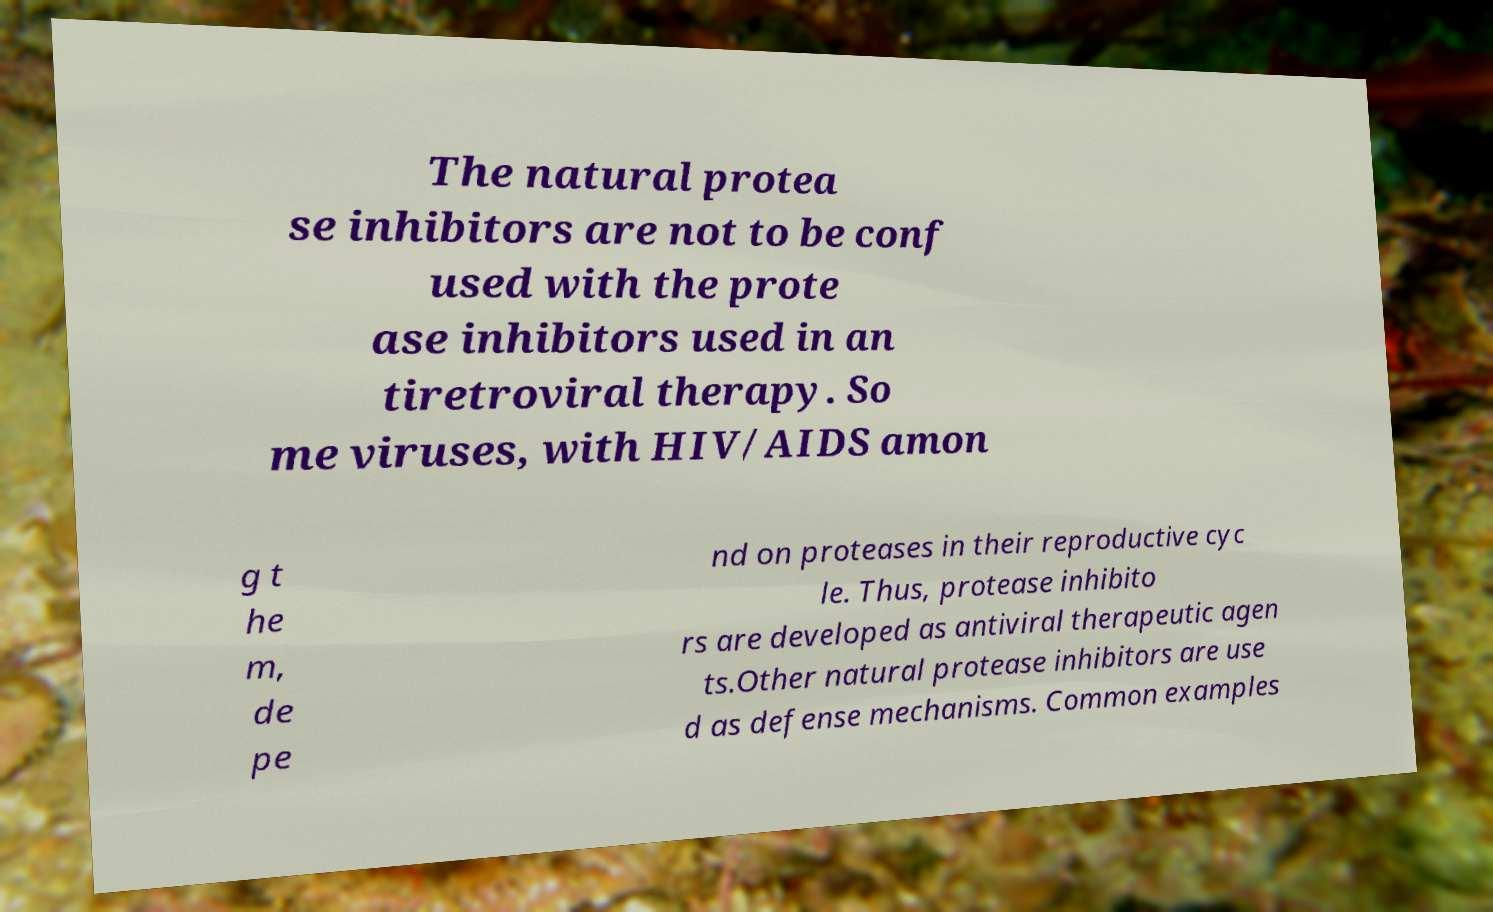Could you extract and type out the text from this image? The natural protea se inhibitors are not to be conf used with the prote ase inhibitors used in an tiretroviral therapy. So me viruses, with HIV/AIDS amon g t he m, de pe nd on proteases in their reproductive cyc le. Thus, protease inhibito rs are developed as antiviral therapeutic agen ts.Other natural protease inhibitors are use d as defense mechanisms. Common examples 